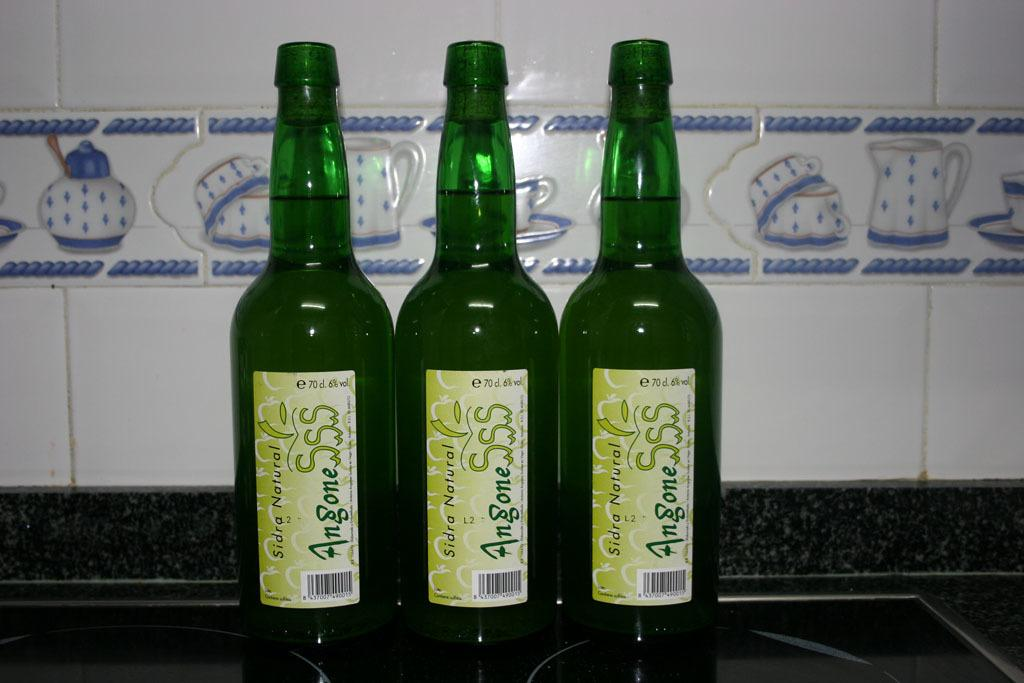<image>
Write a terse but informative summary of the picture. bottles on a counter that say angone on them 